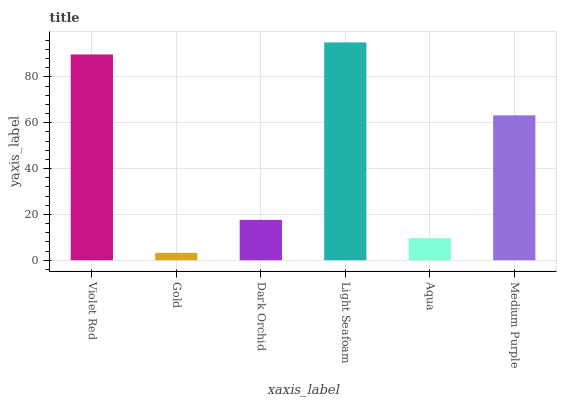Is Dark Orchid the minimum?
Answer yes or no. No. Is Dark Orchid the maximum?
Answer yes or no. No. Is Dark Orchid greater than Gold?
Answer yes or no. Yes. Is Gold less than Dark Orchid?
Answer yes or no. Yes. Is Gold greater than Dark Orchid?
Answer yes or no. No. Is Dark Orchid less than Gold?
Answer yes or no. No. Is Medium Purple the high median?
Answer yes or no. Yes. Is Dark Orchid the low median?
Answer yes or no. Yes. Is Aqua the high median?
Answer yes or no. No. Is Light Seafoam the low median?
Answer yes or no. No. 